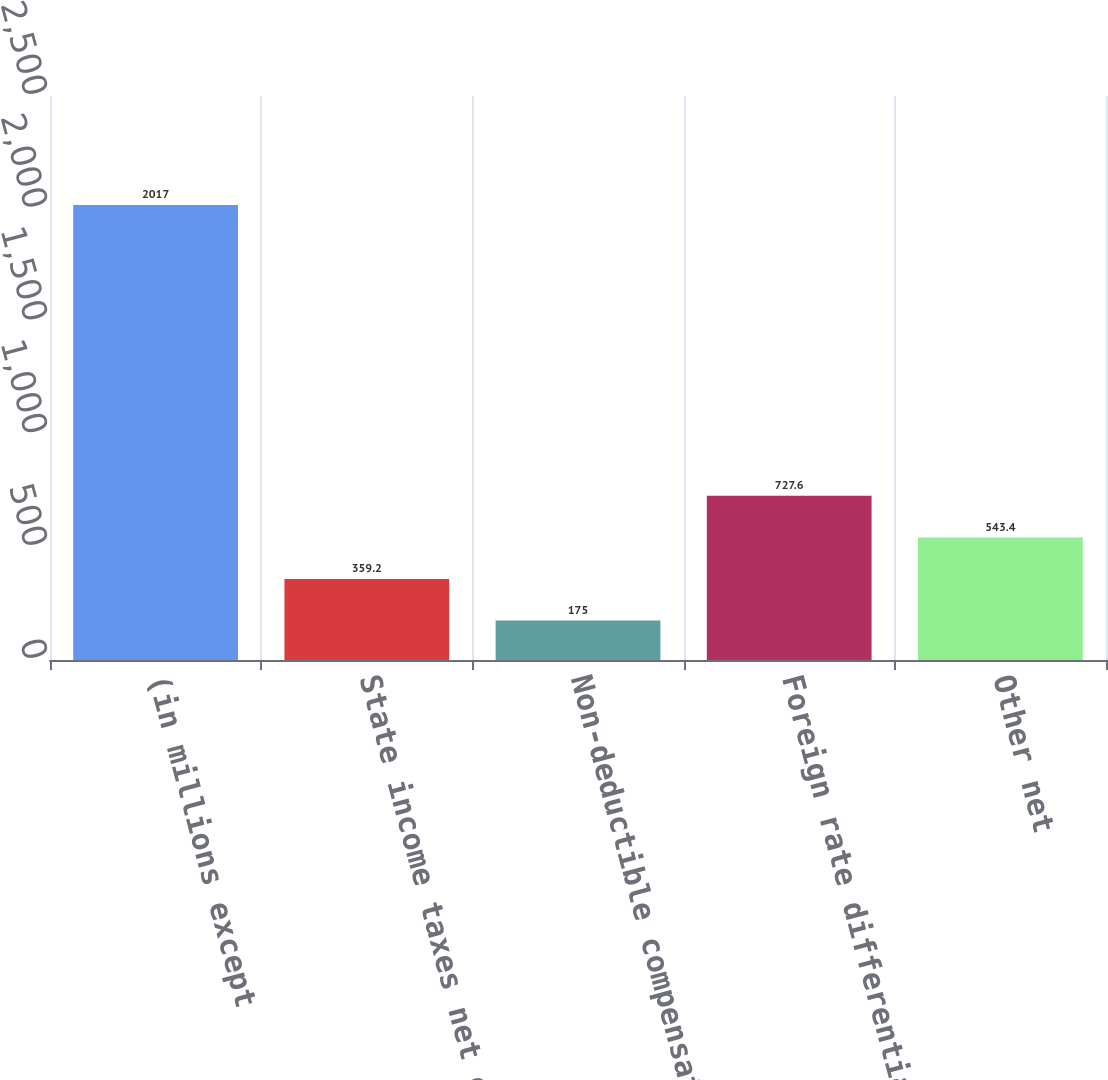<chart> <loc_0><loc_0><loc_500><loc_500><bar_chart><fcel>(in millions except<fcel>State income taxes net of<fcel>Non-deductible compensation<fcel>Foreign rate differential<fcel>Other net<nl><fcel>2017<fcel>359.2<fcel>175<fcel>727.6<fcel>543.4<nl></chart> 